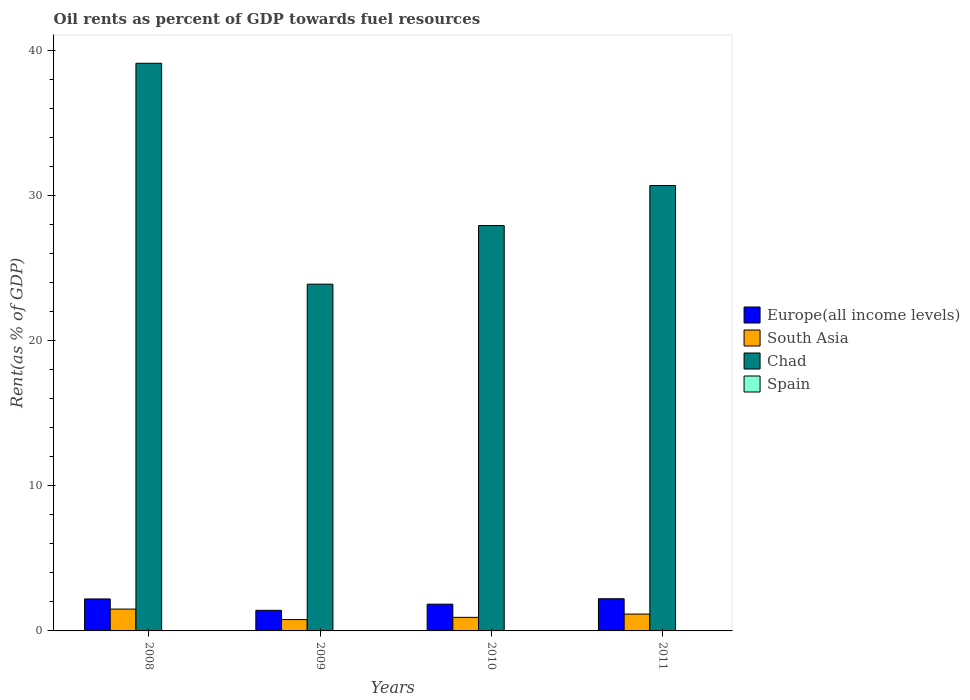How many groups of bars are there?
Provide a short and direct response. 4. What is the label of the 1st group of bars from the left?
Make the answer very short. 2008. In how many cases, is the number of bars for a given year not equal to the number of legend labels?
Give a very brief answer. 0. What is the oil rent in South Asia in 2010?
Provide a succinct answer. 0.93. Across all years, what is the maximum oil rent in Chad?
Ensure brevity in your answer.  39.11. Across all years, what is the minimum oil rent in Spain?
Offer a terse response. 0. In which year was the oil rent in Chad maximum?
Give a very brief answer. 2008. What is the total oil rent in South Asia in the graph?
Your response must be concise. 4.38. What is the difference between the oil rent in South Asia in 2008 and that in 2009?
Ensure brevity in your answer.  0.72. What is the difference between the oil rent in Europe(all income levels) in 2011 and the oil rent in South Asia in 2010?
Your answer should be very brief. 1.28. What is the average oil rent in South Asia per year?
Provide a succinct answer. 1.1. In the year 2008, what is the difference between the oil rent in Chad and oil rent in Europe(all income levels)?
Keep it short and to the point. 36.9. In how many years, is the oil rent in South Asia greater than 2 %?
Your answer should be very brief. 0. What is the ratio of the oil rent in South Asia in 2008 to that in 2010?
Ensure brevity in your answer.  1.61. Is the oil rent in Spain in 2009 less than that in 2010?
Keep it short and to the point. Yes. What is the difference between the highest and the second highest oil rent in Europe(all income levels)?
Provide a short and direct response. 0.01. What is the difference between the highest and the lowest oil rent in Europe(all income levels)?
Your response must be concise. 0.8. Is it the case that in every year, the sum of the oil rent in Spain and oil rent in Chad is greater than the sum of oil rent in Europe(all income levels) and oil rent in South Asia?
Provide a short and direct response. Yes. What does the 2nd bar from the left in 2009 represents?
Offer a terse response. South Asia. What does the 3rd bar from the right in 2009 represents?
Ensure brevity in your answer.  South Asia. How many bars are there?
Offer a terse response. 16. Are all the bars in the graph horizontal?
Provide a short and direct response. No. What is the difference between two consecutive major ticks on the Y-axis?
Your response must be concise. 10. Are the values on the major ticks of Y-axis written in scientific E-notation?
Your response must be concise. No. Does the graph contain any zero values?
Give a very brief answer. No. How many legend labels are there?
Your response must be concise. 4. How are the legend labels stacked?
Your response must be concise. Vertical. What is the title of the graph?
Offer a terse response. Oil rents as percent of GDP towards fuel resources. What is the label or title of the X-axis?
Ensure brevity in your answer.  Years. What is the label or title of the Y-axis?
Your answer should be very brief. Rent(as % of GDP). What is the Rent(as % of GDP) of Europe(all income levels) in 2008?
Keep it short and to the point. 2.2. What is the Rent(as % of GDP) in South Asia in 2008?
Your answer should be very brief. 1.5. What is the Rent(as % of GDP) of Chad in 2008?
Make the answer very short. 39.11. What is the Rent(as % of GDP) in Spain in 2008?
Offer a very short reply. 0. What is the Rent(as % of GDP) of Europe(all income levels) in 2009?
Your answer should be very brief. 1.42. What is the Rent(as % of GDP) of South Asia in 2009?
Make the answer very short. 0.78. What is the Rent(as % of GDP) of Chad in 2009?
Offer a very short reply. 23.89. What is the Rent(as % of GDP) of Spain in 2009?
Make the answer very short. 0. What is the Rent(as % of GDP) in Europe(all income levels) in 2010?
Offer a terse response. 1.84. What is the Rent(as % of GDP) of South Asia in 2010?
Ensure brevity in your answer.  0.93. What is the Rent(as % of GDP) in Chad in 2010?
Make the answer very short. 27.93. What is the Rent(as % of GDP) in Spain in 2010?
Ensure brevity in your answer.  0. What is the Rent(as % of GDP) of Europe(all income levels) in 2011?
Offer a very short reply. 2.22. What is the Rent(as % of GDP) of South Asia in 2011?
Give a very brief answer. 1.16. What is the Rent(as % of GDP) in Chad in 2011?
Provide a succinct answer. 30.68. What is the Rent(as % of GDP) in Spain in 2011?
Make the answer very short. 0. Across all years, what is the maximum Rent(as % of GDP) in Europe(all income levels)?
Offer a very short reply. 2.22. Across all years, what is the maximum Rent(as % of GDP) of South Asia?
Provide a succinct answer. 1.5. Across all years, what is the maximum Rent(as % of GDP) of Chad?
Offer a very short reply. 39.11. Across all years, what is the maximum Rent(as % of GDP) in Spain?
Keep it short and to the point. 0. Across all years, what is the minimum Rent(as % of GDP) in Europe(all income levels)?
Offer a terse response. 1.42. Across all years, what is the minimum Rent(as % of GDP) of South Asia?
Your answer should be compact. 0.78. Across all years, what is the minimum Rent(as % of GDP) in Chad?
Make the answer very short. 23.89. Across all years, what is the minimum Rent(as % of GDP) of Spain?
Give a very brief answer. 0. What is the total Rent(as % of GDP) in Europe(all income levels) in the graph?
Provide a short and direct response. 7.68. What is the total Rent(as % of GDP) in South Asia in the graph?
Ensure brevity in your answer.  4.38. What is the total Rent(as % of GDP) in Chad in the graph?
Make the answer very short. 121.6. What is the total Rent(as % of GDP) of Spain in the graph?
Provide a succinct answer. 0.02. What is the difference between the Rent(as % of GDP) in Europe(all income levels) in 2008 and that in 2009?
Make the answer very short. 0.78. What is the difference between the Rent(as % of GDP) in South Asia in 2008 and that in 2009?
Your answer should be very brief. 0.72. What is the difference between the Rent(as % of GDP) in Chad in 2008 and that in 2009?
Offer a very short reply. 15.22. What is the difference between the Rent(as % of GDP) in Spain in 2008 and that in 2009?
Provide a succinct answer. 0. What is the difference between the Rent(as % of GDP) in Europe(all income levels) in 2008 and that in 2010?
Provide a short and direct response. 0.36. What is the difference between the Rent(as % of GDP) of South Asia in 2008 and that in 2010?
Give a very brief answer. 0.57. What is the difference between the Rent(as % of GDP) of Chad in 2008 and that in 2010?
Ensure brevity in your answer.  11.18. What is the difference between the Rent(as % of GDP) of Spain in 2008 and that in 2010?
Provide a succinct answer. 0. What is the difference between the Rent(as % of GDP) of Europe(all income levels) in 2008 and that in 2011?
Your answer should be compact. -0.01. What is the difference between the Rent(as % of GDP) of South Asia in 2008 and that in 2011?
Offer a terse response. 0.34. What is the difference between the Rent(as % of GDP) in Chad in 2008 and that in 2011?
Keep it short and to the point. 8.42. What is the difference between the Rent(as % of GDP) in Spain in 2008 and that in 2011?
Offer a terse response. 0. What is the difference between the Rent(as % of GDP) in Europe(all income levels) in 2009 and that in 2010?
Your answer should be compact. -0.42. What is the difference between the Rent(as % of GDP) of South Asia in 2009 and that in 2010?
Your answer should be very brief. -0.15. What is the difference between the Rent(as % of GDP) in Chad in 2009 and that in 2010?
Ensure brevity in your answer.  -4.04. What is the difference between the Rent(as % of GDP) in Spain in 2009 and that in 2010?
Offer a very short reply. -0. What is the difference between the Rent(as % of GDP) in Europe(all income levels) in 2009 and that in 2011?
Keep it short and to the point. -0.8. What is the difference between the Rent(as % of GDP) in South Asia in 2009 and that in 2011?
Your response must be concise. -0.38. What is the difference between the Rent(as % of GDP) in Chad in 2009 and that in 2011?
Provide a short and direct response. -6.8. What is the difference between the Rent(as % of GDP) of Spain in 2009 and that in 2011?
Offer a terse response. -0. What is the difference between the Rent(as % of GDP) in Europe(all income levels) in 2010 and that in 2011?
Provide a succinct answer. -0.37. What is the difference between the Rent(as % of GDP) in South Asia in 2010 and that in 2011?
Your answer should be compact. -0.23. What is the difference between the Rent(as % of GDP) of Chad in 2010 and that in 2011?
Give a very brief answer. -2.76. What is the difference between the Rent(as % of GDP) in Spain in 2010 and that in 2011?
Keep it short and to the point. -0. What is the difference between the Rent(as % of GDP) of Europe(all income levels) in 2008 and the Rent(as % of GDP) of South Asia in 2009?
Give a very brief answer. 1.42. What is the difference between the Rent(as % of GDP) in Europe(all income levels) in 2008 and the Rent(as % of GDP) in Chad in 2009?
Offer a terse response. -21.68. What is the difference between the Rent(as % of GDP) of Europe(all income levels) in 2008 and the Rent(as % of GDP) of Spain in 2009?
Provide a short and direct response. 2.2. What is the difference between the Rent(as % of GDP) of South Asia in 2008 and the Rent(as % of GDP) of Chad in 2009?
Your answer should be compact. -22.38. What is the difference between the Rent(as % of GDP) of South Asia in 2008 and the Rent(as % of GDP) of Spain in 2009?
Give a very brief answer. 1.5. What is the difference between the Rent(as % of GDP) of Chad in 2008 and the Rent(as % of GDP) of Spain in 2009?
Offer a terse response. 39.1. What is the difference between the Rent(as % of GDP) in Europe(all income levels) in 2008 and the Rent(as % of GDP) in South Asia in 2010?
Provide a succinct answer. 1.27. What is the difference between the Rent(as % of GDP) in Europe(all income levels) in 2008 and the Rent(as % of GDP) in Chad in 2010?
Provide a succinct answer. -25.72. What is the difference between the Rent(as % of GDP) in Europe(all income levels) in 2008 and the Rent(as % of GDP) in Spain in 2010?
Ensure brevity in your answer.  2.2. What is the difference between the Rent(as % of GDP) of South Asia in 2008 and the Rent(as % of GDP) of Chad in 2010?
Keep it short and to the point. -26.42. What is the difference between the Rent(as % of GDP) of South Asia in 2008 and the Rent(as % of GDP) of Spain in 2010?
Provide a short and direct response. 1.5. What is the difference between the Rent(as % of GDP) in Chad in 2008 and the Rent(as % of GDP) in Spain in 2010?
Make the answer very short. 39.1. What is the difference between the Rent(as % of GDP) of Europe(all income levels) in 2008 and the Rent(as % of GDP) of South Asia in 2011?
Give a very brief answer. 1.04. What is the difference between the Rent(as % of GDP) in Europe(all income levels) in 2008 and the Rent(as % of GDP) in Chad in 2011?
Provide a succinct answer. -28.48. What is the difference between the Rent(as % of GDP) of Europe(all income levels) in 2008 and the Rent(as % of GDP) of Spain in 2011?
Ensure brevity in your answer.  2.2. What is the difference between the Rent(as % of GDP) in South Asia in 2008 and the Rent(as % of GDP) in Chad in 2011?
Provide a succinct answer. -29.18. What is the difference between the Rent(as % of GDP) in South Asia in 2008 and the Rent(as % of GDP) in Spain in 2011?
Offer a terse response. 1.5. What is the difference between the Rent(as % of GDP) of Chad in 2008 and the Rent(as % of GDP) of Spain in 2011?
Provide a succinct answer. 39.1. What is the difference between the Rent(as % of GDP) of Europe(all income levels) in 2009 and the Rent(as % of GDP) of South Asia in 2010?
Provide a succinct answer. 0.48. What is the difference between the Rent(as % of GDP) in Europe(all income levels) in 2009 and the Rent(as % of GDP) in Chad in 2010?
Provide a succinct answer. -26.51. What is the difference between the Rent(as % of GDP) in Europe(all income levels) in 2009 and the Rent(as % of GDP) in Spain in 2010?
Your response must be concise. 1.41. What is the difference between the Rent(as % of GDP) of South Asia in 2009 and the Rent(as % of GDP) of Chad in 2010?
Offer a terse response. -27.15. What is the difference between the Rent(as % of GDP) in South Asia in 2009 and the Rent(as % of GDP) in Spain in 2010?
Your answer should be compact. 0.78. What is the difference between the Rent(as % of GDP) of Chad in 2009 and the Rent(as % of GDP) of Spain in 2010?
Offer a terse response. 23.88. What is the difference between the Rent(as % of GDP) in Europe(all income levels) in 2009 and the Rent(as % of GDP) in South Asia in 2011?
Your answer should be compact. 0.26. What is the difference between the Rent(as % of GDP) of Europe(all income levels) in 2009 and the Rent(as % of GDP) of Chad in 2011?
Your answer should be very brief. -29.26. What is the difference between the Rent(as % of GDP) in Europe(all income levels) in 2009 and the Rent(as % of GDP) in Spain in 2011?
Ensure brevity in your answer.  1.41. What is the difference between the Rent(as % of GDP) in South Asia in 2009 and the Rent(as % of GDP) in Chad in 2011?
Make the answer very short. -29.9. What is the difference between the Rent(as % of GDP) in South Asia in 2009 and the Rent(as % of GDP) in Spain in 2011?
Keep it short and to the point. 0.78. What is the difference between the Rent(as % of GDP) of Chad in 2009 and the Rent(as % of GDP) of Spain in 2011?
Offer a very short reply. 23.88. What is the difference between the Rent(as % of GDP) of Europe(all income levels) in 2010 and the Rent(as % of GDP) of South Asia in 2011?
Make the answer very short. 0.68. What is the difference between the Rent(as % of GDP) in Europe(all income levels) in 2010 and the Rent(as % of GDP) in Chad in 2011?
Provide a succinct answer. -28.84. What is the difference between the Rent(as % of GDP) in Europe(all income levels) in 2010 and the Rent(as % of GDP) in Spain in 2011?
Offer a terse response. 1.84. What is the difference between the Rent(as % of GDP) of South Asia in 2010 and the Rent(as % of GDP) of Chad in 2011?
Keep it short and to the point. -29.75. What is the difference between the Rent(as % of GDP) of South Asia in 2010 and the Rent(as % of GDP) of Spain in 2011?
Give a very brief answer. 0.93. What is the difference between the Rent(as % of GDP) in Chad in 2010 and the Rent(as % of GDP) in Spain in 2011?
Your response must be concise. 27.92. What is the average Rent(as % of GDP) in Europe(all income levels) per year?
Provide a succinct answer. 1.92. What is the average Rent(as % of GDP) in South Asia per year?
Ensure brevity in your answer.  1.1. What is the average Rent(as % of GDP) of Chad per year?
Provide a short and direct response. 30.4. What is the average Rent(as % of GDP) of Spain per year?
Offer a terse response. 0. In the year 2008, what is the difference between the Rent(as % of GDP) in Europe(all income levels) and Rent(as % of GDP) in South Asia?
Provide a succinct answer. 0.7. In the year 2008, what is the difference between the Rent(as % of GDP) of Europe(all income levels) and Rent(as % of GDP) of Chad?
Keep it short and to the point. -36.9. In the year 2008, what is the difference between the Rent(as % of GDP) of Europe(all income levels) and Rent(as % of GDP) of Spain?
Give a very brief answer. 2.2. In the year 2008, what is the difference between the Rent(as % of GDP) in South Asia and Rent(as % of GDP) in Chad?
Your answer should be compact. -37.6. In the year 2008, what is the difference between the Rent(as % of GDP) in Chad and Rent(as % of GDP) in Spain?
Offer a very short reply. 39.1. In the year 2009, what is the difference between the Rent(as % of GDP) in Europe(all income levels) and Rent(as % of GDP) in South Asia?
Your answer should be very brief. 0.64. In the year 2009, what is the difference between the Rent(as % of GDP) in Europe(all income levels) and Rent(as % of GDP) in Chad?
Provide a succinct answer. -22.47. In the year 2009, what is the difference between the Rent(as % of GDP) of Europe(all income levels) and Rent(as % of GDP) of Spain?
Your answer should be very brief. 1.42. In the year 2009, what is the difference between the Rent(as % of GDP) of South Asia and Rent(as % of GDP) of Chad?
Ensure brevity in your answer.  -23.11. In the year 2009, what is the difference between the Rent(as % of GDP) of South Asia and Rent(as % of GDP) of Spain?
Your answer should be very brief. 0.78. In the year 2009, what is the difference between the Rent(as % of GDP) of Chad and Rent(as % of GDP) of Spain?
Keep it short and to the point. 23.88. In the year 2010, what is the difference between the Rent(as % of GDP) of Europe(all income levels) and Rent(as % of GDP) of South Asia?
Ensure brevity in your answer.  0.91. In the year 2010, what is the difference between the Rent(as % of GDP) in Europe(all income levels) and Rent(as % of GDP) in Chad?
Your answer should be very brief. -26.09. In the year 2010, what is the difference between the Rent(as % of GDP) in Europe(all income levels) and Rent(as % of GDP) in Spain?
Give a very brief answer. 1.84. In the year 2010, what is the difference between the Rent(as % of GDP) in South Asia and Rent(as % of GDP) in Chad?
Provide a succinct answer. -26.99. In the year 2010, what is the difference between the Rent(as % of GDP) in South Asia and Rent(as % of GDP) in Spain?
Provide a short and direct response. 0.93. In the year 2010, what is the difference between the Rent(as % of GDP) in Chad and Rent(as % of GDP) in Spain?
Provide a succinct answer. 27.92. In the year 2011, what is the difference between the Rent(as % of GDP) of Europe(all income levels) and Rent(as % of GDP) of South Asia?
Ensure brevity in your answer.  1.06. In the year 2011, what is the difference between the Rent(as % of GDP) of Europe(all income levels) and Rent(as % of GDP) of Chad?
Your answer should be compact. -28.47. In the year 2011, what is the difference between the Rent(as % of GDP) of Europe(all income levels) and Rent(as % of GDP) of Spain?
Provide a short and direct response. 2.21. In the year 2011, what is the difference between the Rent(as % of GDP) of South Asia and Rent(as % of GDP) of Chad?
Your answer should be compact. -29.52. In the year 2011, what is the difference between the Rent(as % of GDP) in South Asia and Rent(as % of GDP) in Spain?
Your response must be concise. 1.16. In the year 2011, what is the difference between the Rent(as % of GDP) of Chad and Rent(as % of GDP) of Spain?
Your response must be concise. 30.68. What is the ratio of the Rent(as % of GDP) in Europe(all income levels) in 2008 to that in 2009?
Provide a succinct answer. 1.55. What is the ratio of the Rent(as % of GDP) of South Asia in 2008 to that in 2009?
Provide a short and direct response. 1.92. What is the ratio of the Rent(as % of GDP) of Chad in 2008 to that in 2009?
Make the answer very short. 1.64. What is the ratio of the Rent(as % of GDP) of Spain in 2008 to that in 2009?
Ensure brevity in your answer.  1.97. What is the ratio of the Rent(as % of GDP) of Europe(all income levels) in 2008 to that in 2010?
Your answer should be compact. 1.2. What is the ratio of the Rent(as % of GDP) of South Asia in 2008 to that in 2010?
Your response must be concise. 1.61. What is the ratio of the Rent(as % of GDP) in Chad in 2008 to that in 2010?
Keep it short and to the point. 1.4. What is the ratio of the Rent(as % of GDP) of Spain in 2008 to that in 2010?
Your answer should be compact. 1.21. What is the ratio of the Rent(as % of GDP) in South Asia in 2008 to that in 2011?
Give a very brief answer. 1.3. What is the ratio of the Rent(as % of GDP) of Chad in 2008 to that in 2011?
Provide a succinct answer. 1.27. What is the ratio of the Rent(as % of GDP) in Spain in 2008 to that in 2011?
Offer a very short reply. 1.16. What is the ratio of the Rent(as % of GDP) in Europe(all income levels) in 2009 to that in 2010?
Offer a terse response. 0.77. What is the ratio of the Rent(as % of GDP) in South Asia in 2009 to that in 2010?
Ensure brevity in your answer.  0.84. What is the ratio of the Rent(as % of GDP) of Chad in 2009 to that in 2010?
Ensure brevity in your answer.  0.86. What is the ratio of the Rent(as % of GDP) in Spain in 2009 to that in 2010?
Provide a short and direct response. 0.61. What is the ratio of the Rent(as % of GDP) in Europe(all income levels) in 2009 to that in 2011?
Your response must be concise. 0.64. What is the ratio of the Rent(as % of GDP) of South Asia in 2009 to that in 2011?
Provide a short and direct response. 0.67. What is the ratio of the Rent(as % of GDP) of Chad in 2009 to that in 2011?
Provide a short and direct response. 0.78. What is the ratio of the Rent(as % of GDP) of Spain in 2009 to that in 2011?
Offer a terse response. 0.59. What is the ratio of the Rent(as % of GDP) in Europe(all income levels) in 2010 to that in 2011?
Provide a short and direct response. 0.83. What is the ratio of the Rent(as % of GDP) in South Asia in 2010 to that in 2011?
Your answer should be very brief. 0.8. What is the ratio of the Rent(as % of GDP) of Chad in 2010 to that in 2011?
Your answer should be very brief. 0.91. What is the ratio of the Rent(as % of GDP) in Spain in 2010 to that in 2011?
Provide a succinct answer. 0.96. What is the difference between the highest and the second highest Rent(as % of GDP) in Europe(all income levels)?
Ensure brevity in your answer.  0.01. What is the difference between the highest and the second highest Rent(as % of GDP) of South Asia?
Make the answer very short. 0.34. What is the difference between the highest and the second highest Rent(as % of GDP) in Chad?
Offer a terse response. 8.42. What is the difference between the highest and the second highest Rent(as % of GDP) in Spain?
Provide a succinct answer. 0. What is the difference between the highest and the lowest Rent(as % of GDP) of Europe(all income levels)?
Keep it short and to the point. 0.8. What is the difference between the highest and the lowest Rent(as % of GDP) in South Asia?
Your answer should be compact. 0.72. What is the difference between the highest and the lowest Rent(as % of GDP) of Chad?
Your answer should be very brief. 15.22. What is the difference between the highest and the lowest Rent(as % of GDP) in Spain?
Offer a very short reply. 0. 